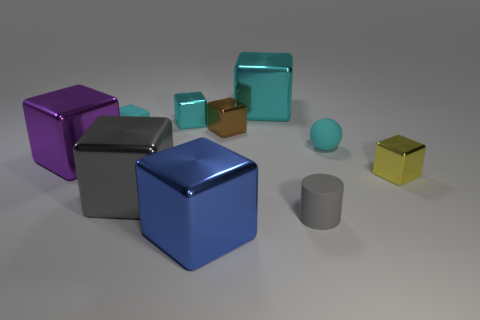Apart from the cubes, what other shapes can you identify? Aside from the cubes, I can identify a cylinder that has a gray color and two spheres, one cyan and one yellow.  Is there a pattern in the arrangement of these objects? The objects don't seem to be arranged in a recognizable pattern; they are placed seemingly at random on the surface in the image. 